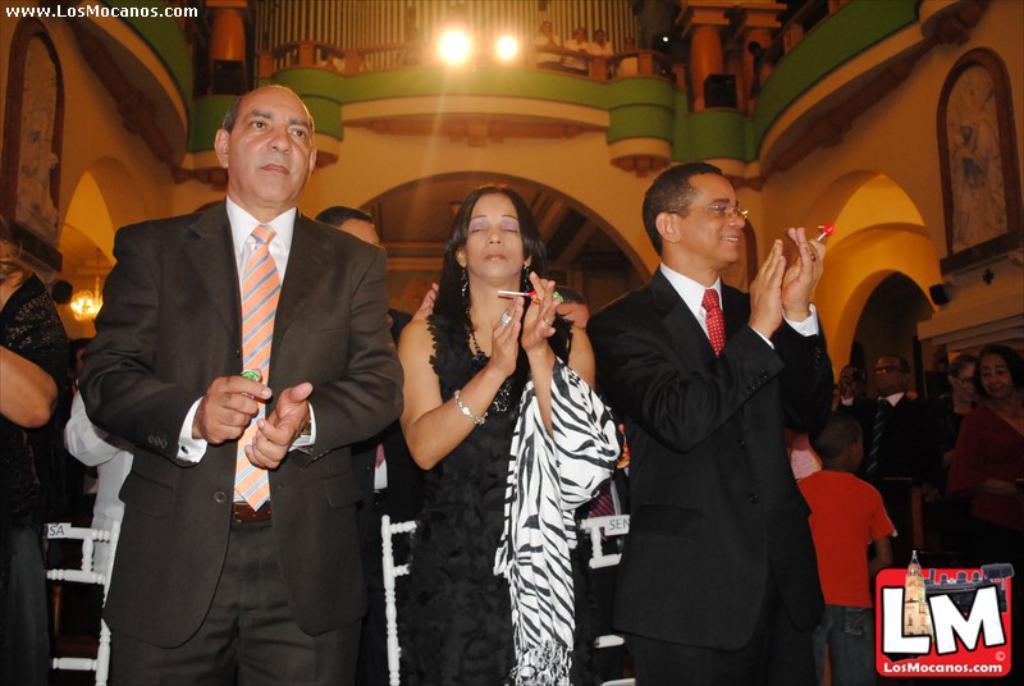Could you give a brief overview of what you see in this image? In this image there are a group of people holding objects and clapping hands, in the background there are paintings on the walls and a few people are standing behind the balcony. 